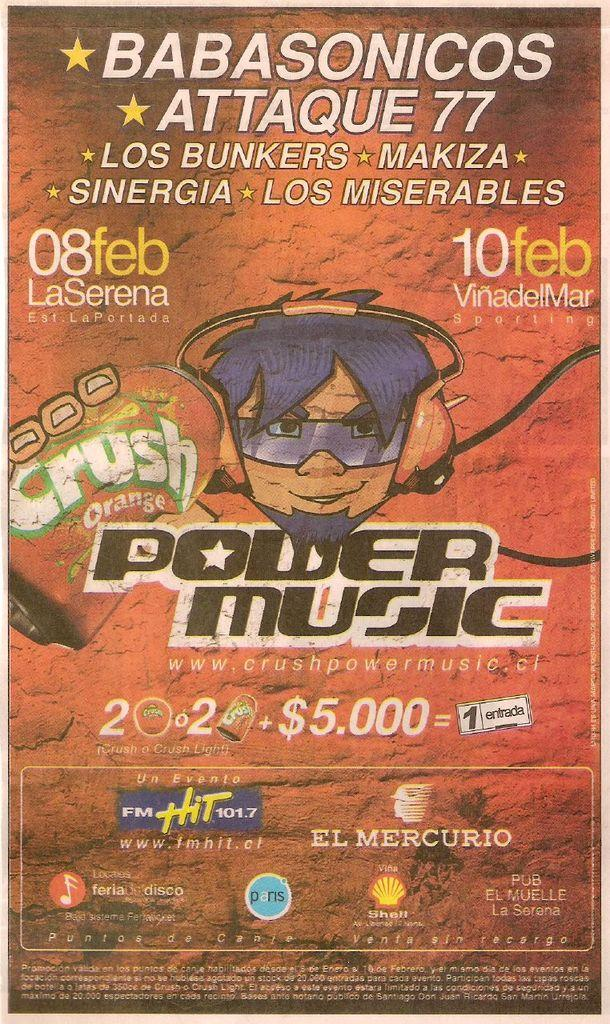<image>
Provide a brief description of the given image. A Power Music advertisement showing a prize of $5,000. 